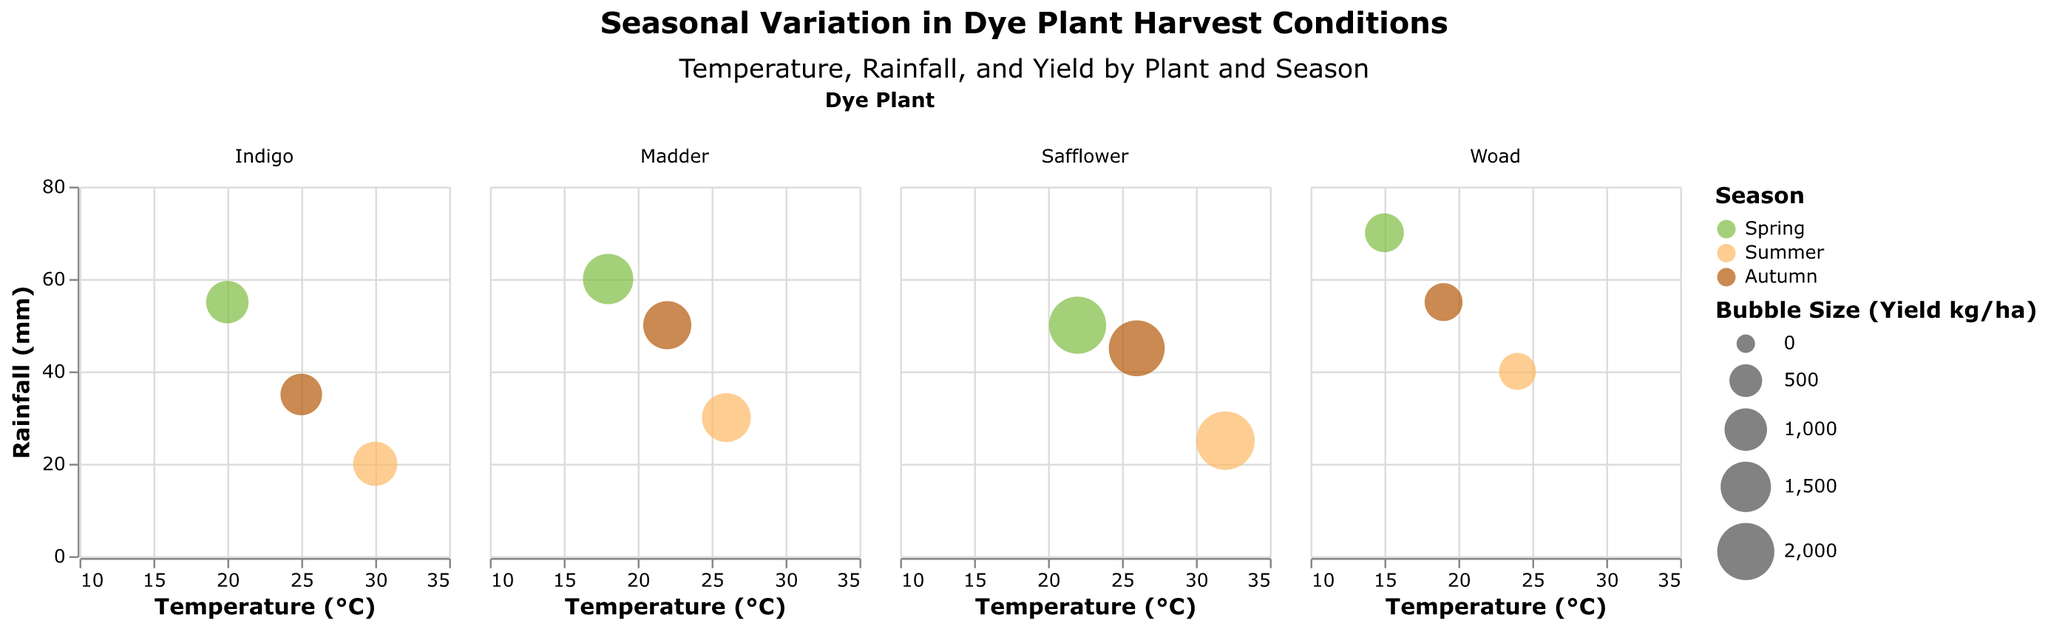What is the title of the figure? The title of the figure is displayed at the top and reads "Seasonal Variation in Dye Plant Harvest Conditions".
Answer: Seasonal Variation in Dye Plant Harvest Conditions What are the axis titles of the chart? The X-axis title is "Temperature (°C)" and the Y-axis title is "Rainfall (mm)". These titles are shown along the respective axes.
Answer: Temperature (°C), Rainfall (mm) Which dye plant has the highest yield in any season? The highest yield is indicated by the largest bubble size. The largest bubble belongs to Safflower in Summer, as seen in the subplot for Safflower.
Answer: Safflower How does the yield of Indigo change from Spring to Autumn? For Indigo, the bubble size decreases from Spring to Autumn. In Spring, the yield is 1000 kg/ha; in Summer, it is 1100 kg/ha; and in Autumn, it drops to 950 kg/ha.
Answer: Decreases Compare the yields of Madder and Woad in Spring. Which one is higher? In Spring, Madder has a yield of 1500 kg/ha, while Woad has a yield of 800 kg/ha. By comparing the bubble sizes, it’s clear that Madder has a higher yield.
Answer: Madder What is the average temperature during the harvest months for Safflower? Safflower is harvested in May (22°C), July (32°C), and October (26°C). The average temperature is calculated as (22 + 32 + 26) / 3 = 80 / 3 ≈ 26.67°C.
Answer: 26.67°C Which season has the highest yield for most of the dye plants? By examining the color and size of the bubbles, we see that Summer (colored #FDB863) has the highest yields for Madder, Indigo, and Safflower.
Answer: Summer What is the range of rainfall levels for Indigo across all seasons? The rainfall levels for Indigo are 55 mm in Spring, 20 mm in Summer, and 35 mm in Autumn. The range of rainfall is the difference between the highest and lowest values: 55 - 20 = 35 mm.
Answer: 35 mm Which dye plant has the lowest yield in Summer, and what is its yield? The smallest bubble in Summer belongs to Woad with a yield of 700 kg/ha. This can be seen in the Summer subplot for Woad.
Answer: Woad, 700 kg/ha 